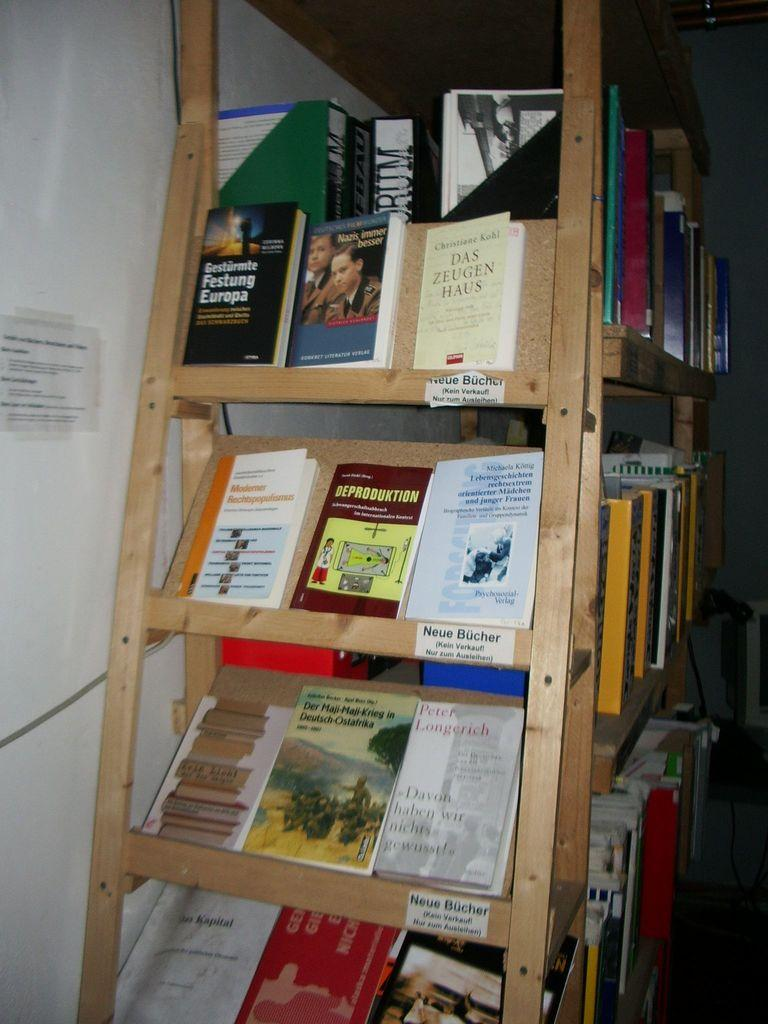<image>
Offer a succinct explanation of the picture presented. A wooden bookshelf has lots of books on it and the shelves say Neue Bucher. 